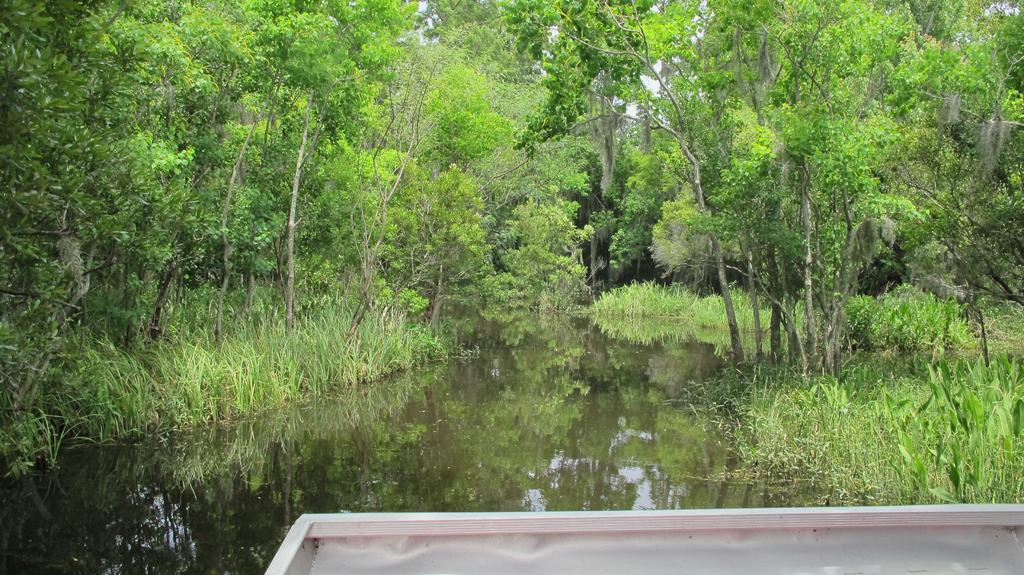How would you summarize this image in a sentence or two? In this image, we can see some trees and plants. There is a lake in the middle of the image. There is an object at the bottom of the image. 